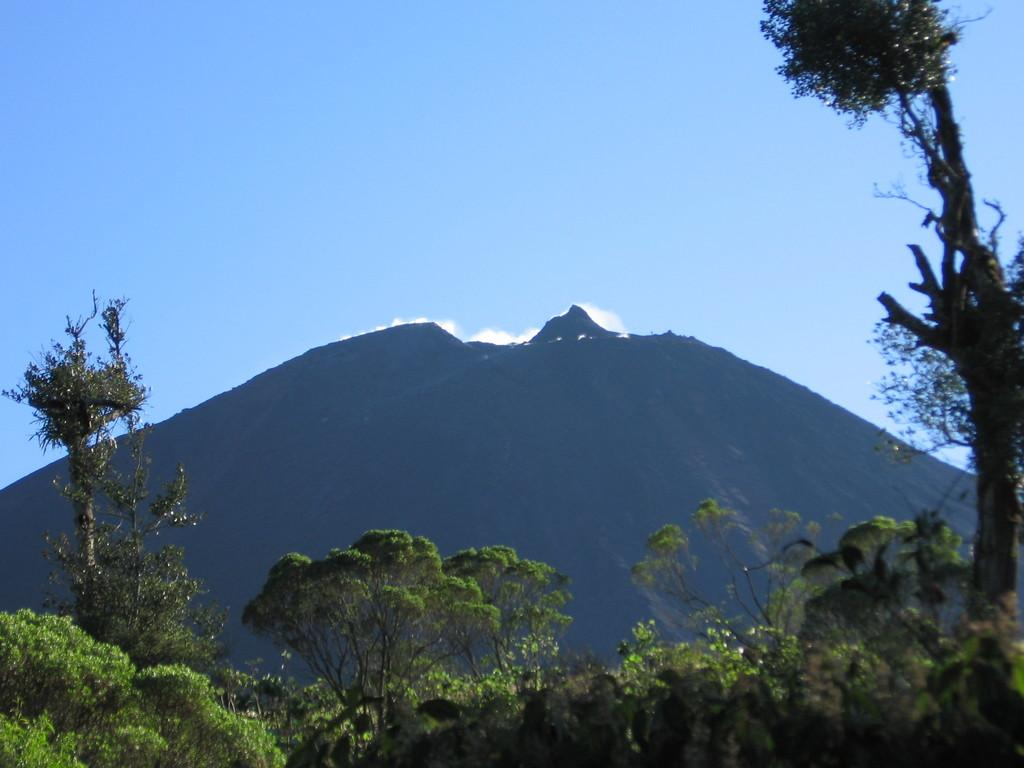What type of vegetation can be seen in the image? There are trees in the image. What is visible in the background of the image? There is a mountain and the sky visible in the background of the image. How many apples does the mom have in the image? There are no apples or mom present in the image. 